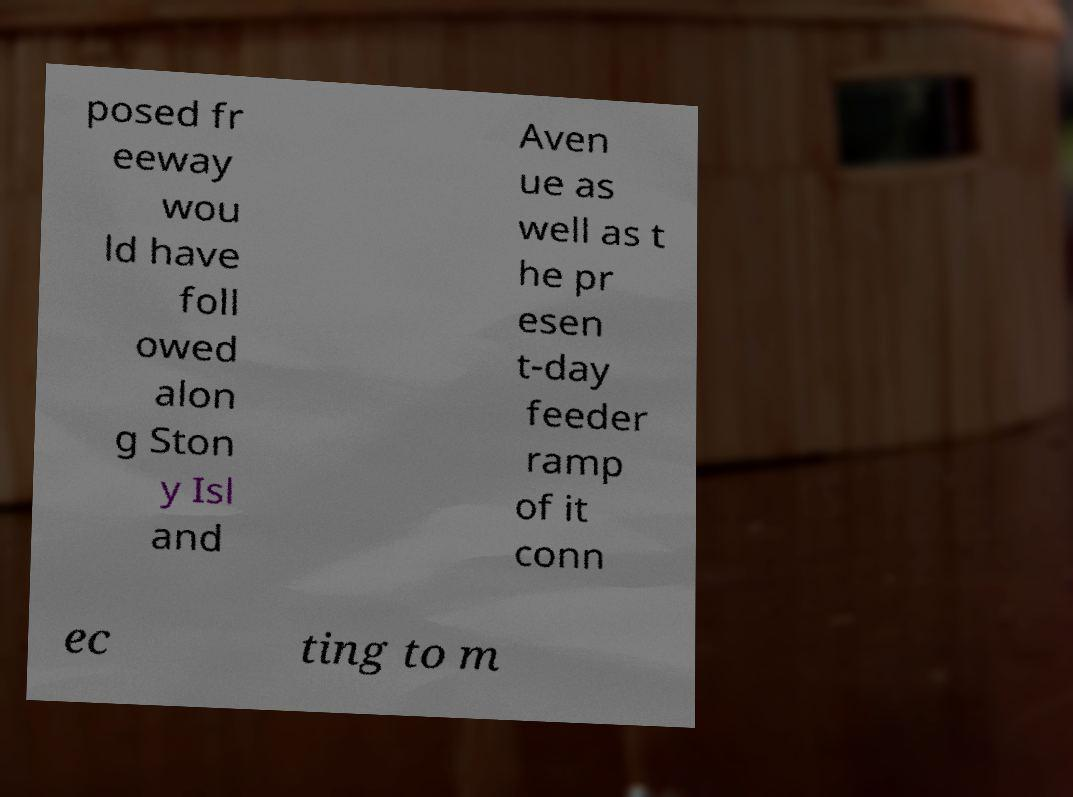What messages or text are displayed in this image? I need them in a readable, typed format. posed fr eeway wou ld have foll owed alon g Ston y Isl and Aven ue as well as t he pr esen t-day feeder ramp of it conn ec ting to m 